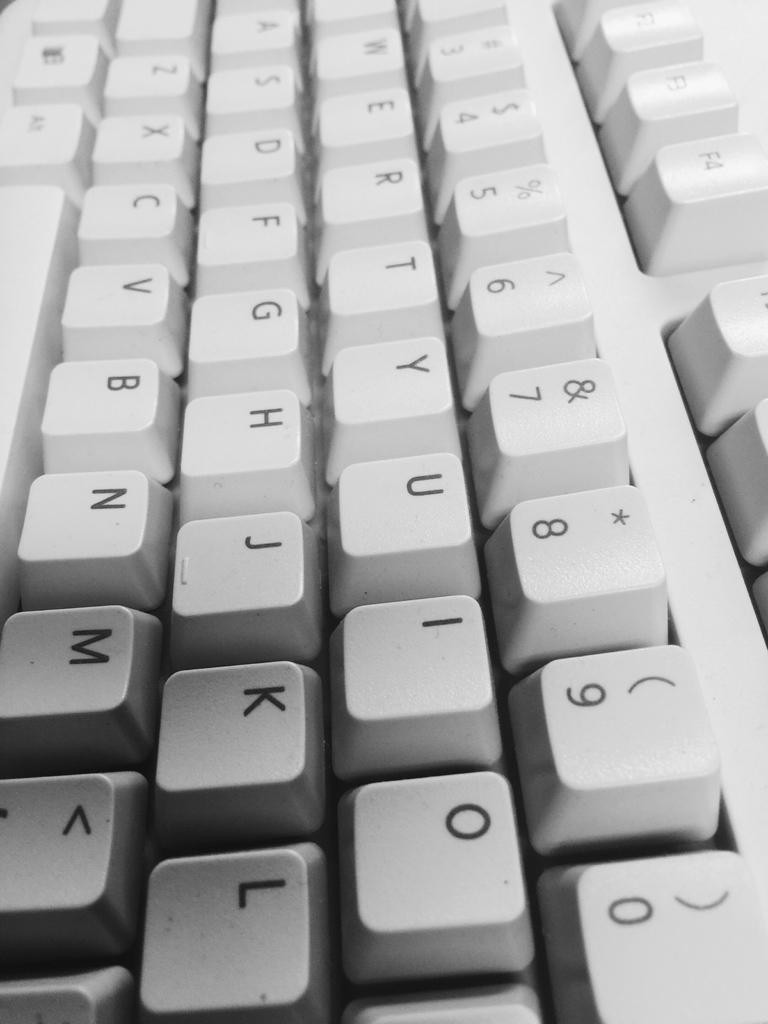<image>
Give a short and clear explanation of the subsequent image. White keyboard with the U key in between the Y and I keys. 